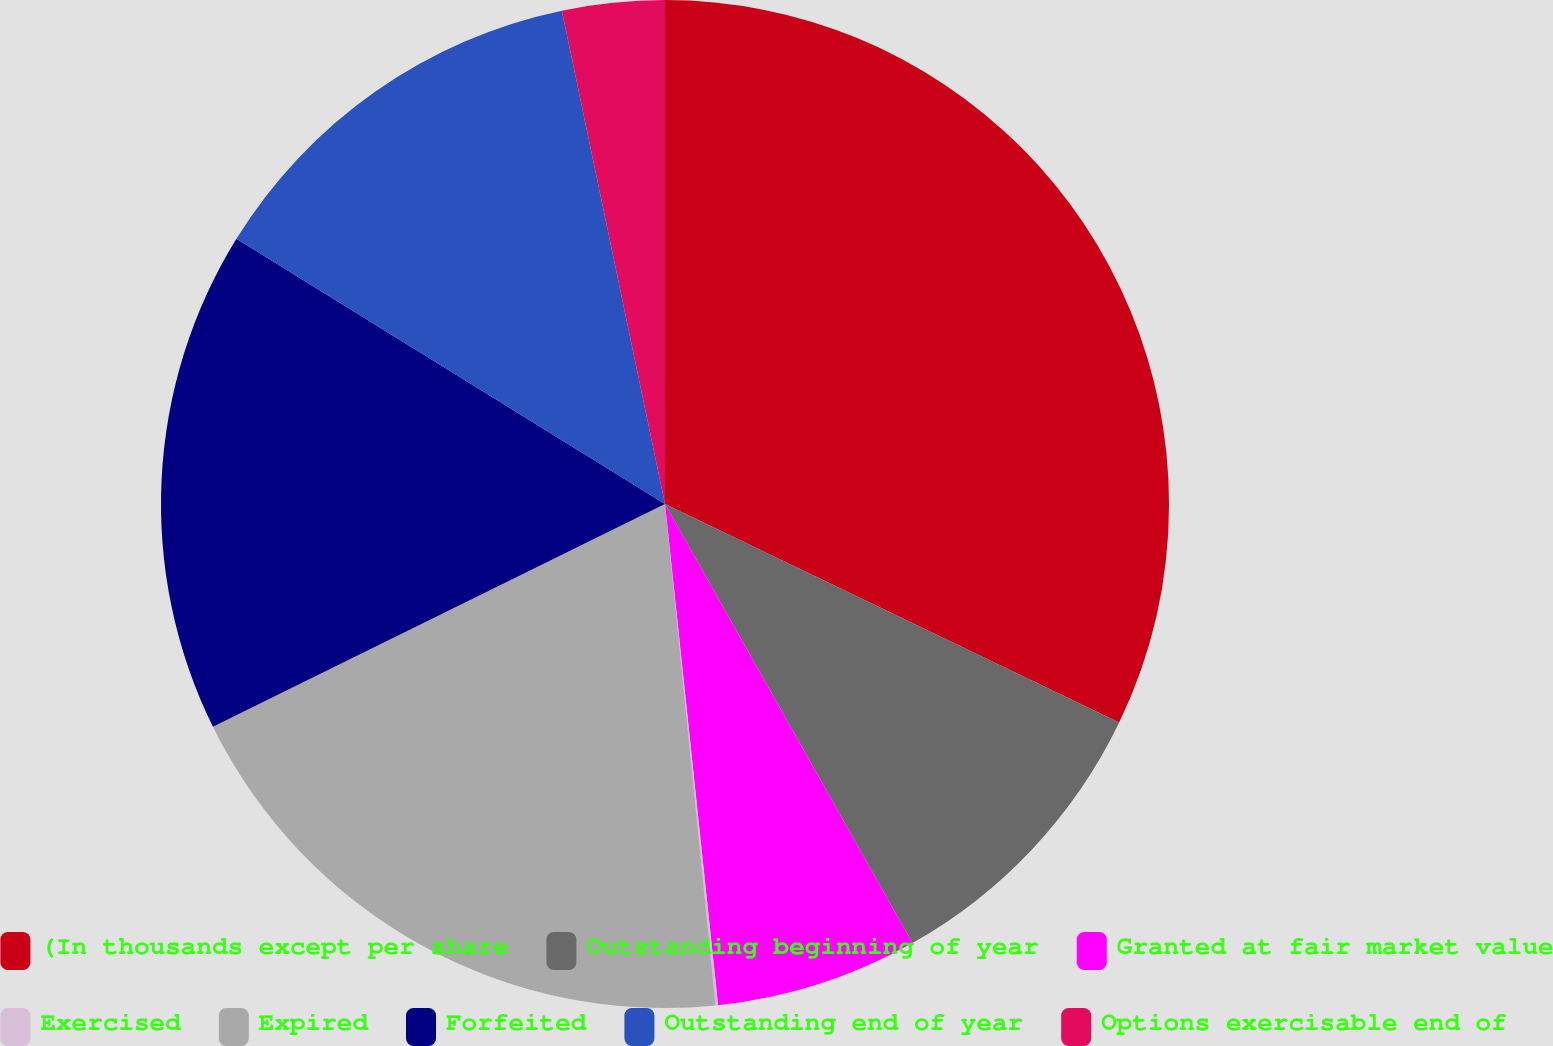<chart> <loc_0><loc_0><loc_500><loc_500><pie_chart><fcel>(In thousands except per share<fcel>Outstanding beginning of year<fcel>Granted at fair market value<fcel>Exercised<fcel>Expired<fcel>Forfeited<fcel>Outstanding end of year<fcel>Options exercisable end of<nl><fcel>32.14%<fcel>9.69%<fcel>6.49%<fcel>0.08%<fcel>19.31%<fcel>16.11%<fcel>12.9%<fcel>3.28%<nl></chart> 